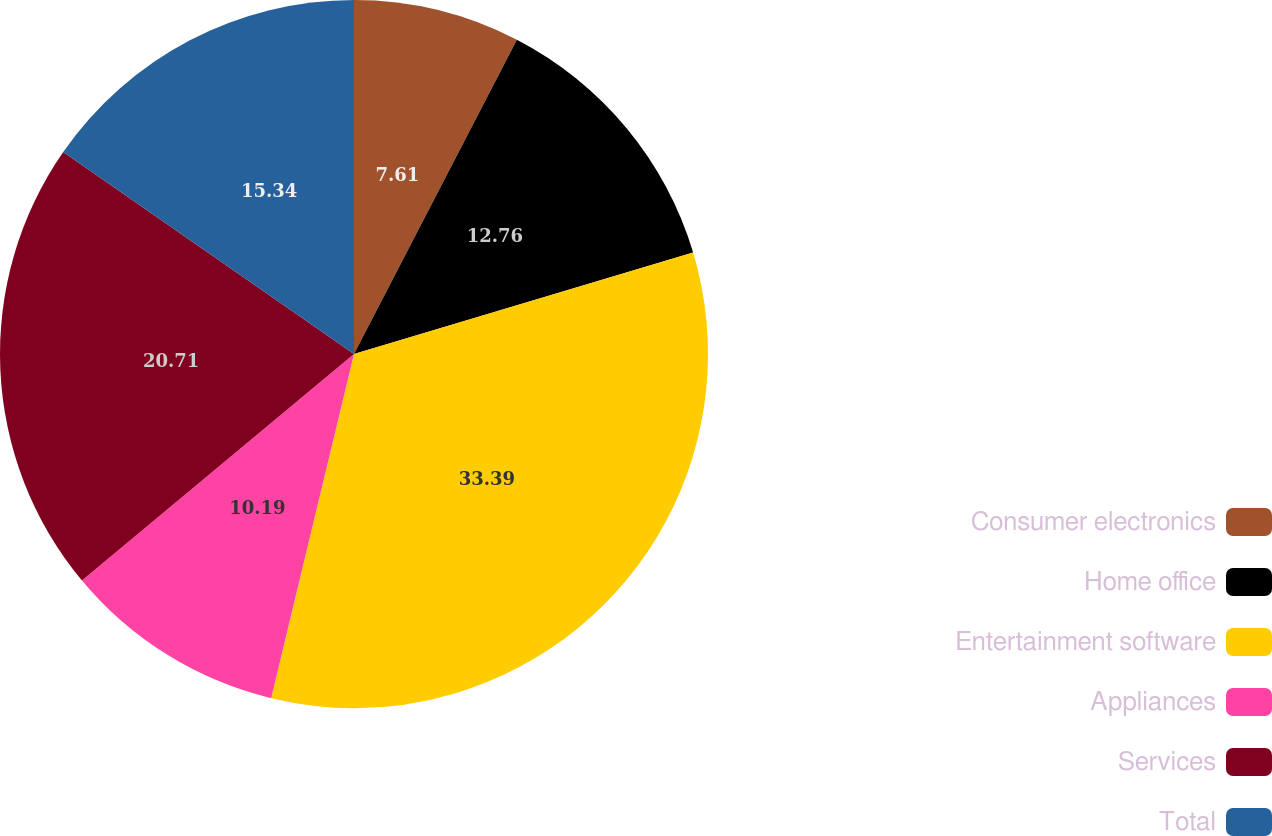<chart> <loc_0><loc_0><loc_500><loc_500><pie_chart><fcel>Consumer electronics<fcel>Home office<fcel>Entertainment software<fcel>Appliances<fcel>Services<fcel>Total<nl><fcel>7.61%<fcel>12.76%<fcel>33.39%<fcel>10.19%<fcel>20.71%<fcel>15.34%<nl></chart> 